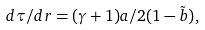<formula> <loc_0><loc_0><loc_500><loc_500>d { \tau } / { d { r } } = ( \gamma + 1 ) a / { 2 ( 1 - \tilde { b } ) } ,</formula> 